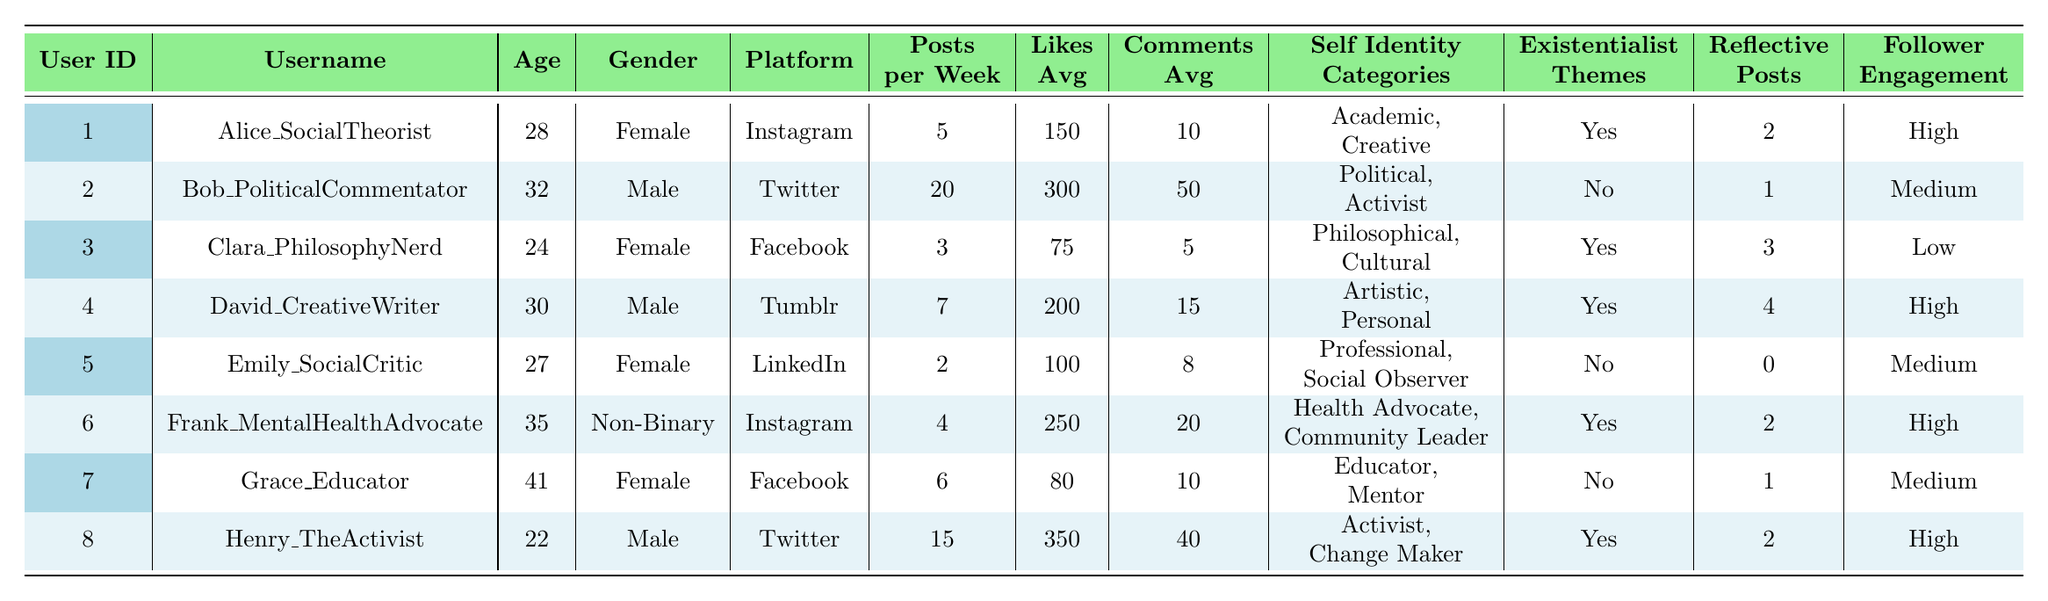What is the most common social media platform among the users? By examining the 'Platform' column for all entries, we can see that Instagram is represented by two users, while Twitter has two users as well, but Facebook and LinkedIn each have only one user. Thus, the most commonly represented platforms are Instagram and Twitter, both with two users.
Answer: Instagram and Twitter Which user has the highest average likes? By reviewing the 'Likes_Avg' column, we can identify the values: Alice has 150, Bob has 300, Clara has 75, David has 200, Emily has 100, Frank has 250, Grace has 80, and Henry has 350. The highest average likes is 350 from Henry.
Answer: Henry Do any users engage with their followers highly and also post reflective content? We check the 'Engagement with Followers' and 'Frequency of Reflective Posts' columns for users with 'High' engagement. Alice and David show 'High' engagement, and both post reflective content (2 and 4 reflective posts, respectively).
Answer: Yes What is the average number of posts each user makes per week? To find the average, sum the 'Posts_per_Week' values (5 + 20 + 3 + 7 + 2 + 4 + 6 + 15 = 62) and divide by the number of users (8). Therefore, the average is 62/8 = 7.75.
Answer: 7.75 Is there a relationship between the presence of existentialist themes and user engagement levels? The users with high engagement (Alice, David, Frank, and Henry) have a presence of existentialist themes, while Clara and Emily do not, and they have low engagement. So, it appears that users with existentialist themes tend to have higher engagement.
Answer: Yes What is the total average for comments made by users? The total number of comments averages to (10 + 50 + 5 + 15 + 8 + 20 + 10 + 40 = 158). Dividing this total by the number of users (8) gives an average of 19.75 comments.
Answer: 19.75 Which user has reflected the most on their posts, and how many reflective posts do they have? Looking at the 'Frequency of Reflective Posts' column, David has the highest number with 4 reflective posts.
Answer: David, 4 How many users have identified as "Activist"? Focusing on the 'Self Identity Categories' column, we find that Bob, Henry, and Frank are listed as "Activist". Therefore, there are three users who have that categorical identification.
Answer: 3 Is the age of users with high engagement mostly over 30? Users with high engagement: Alice (28), David (30), Frank (35), and Henry (22) have an average age of (28 + 30 + 35 + 22)/4 = 28.75, which indicates that most are not over 30.
Answer: No What is the ratio of reflective posts to average likes for the user with the most reflective posts? David has 4 reflective posts and 200 likes. The ratio is 4 reflective posts / 200 likes = 0.02 ratio of reflective posts to likes.
Answer: 0.02 